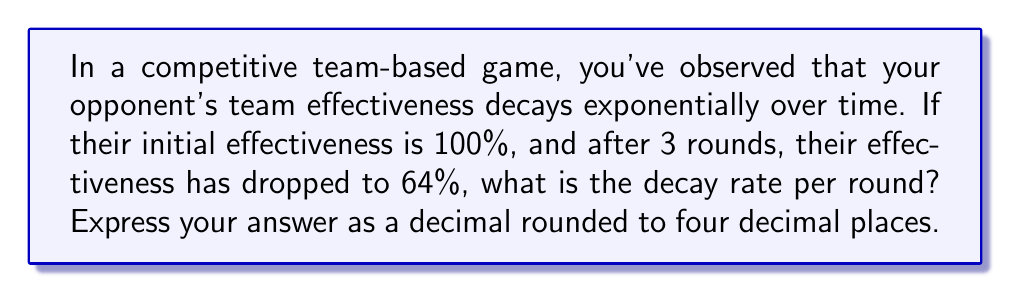What is the answer to this math problem? Let's approach this step-by-step:

1) Let $r$ be the decay rate per round. This means that after each round, the effectiveness is multiplied by $(1-r)$.

2) We can express this as an exponential decay function:
   $$ E(t) = E_0 \cdot (1-r)^t $$
   Where $E(t)$ is the effectiveness at time $t$, $E_0$ is the initial effectiveness, and $t$ is the number of rounds.

3) We know:
   - $E_0 = 100\%$
   - After 3 rounds $(t=3)$, $E(3) = 64\%$

4) Let's plug these values into our equation:
   $$ 64 = 100 \cdot (1-r)^3 $$

5) Divide both sides by 100:
   $$ 0.64 = (1-r)^3 $$

6) Take the cube root of both sides:
   $$ \sqrt[3]{0.64} = 1-r $$

7) Solve for $r$:
   $$ r = 1 - \sqrt[3]{0.64} $$

8) Calculate:
   $$ r = 1 - 0.8615277841 = 0.1384722159 $$

9) Rounding to four decimal places:
   $$ r \approx 0.1385 $$
Answer: $0.1385$ 